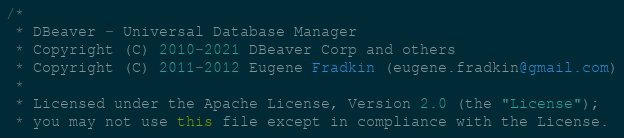<code> <loc_0><loc_0><loc_500><loc_500><_Java_>/*
 * DBeaver - Universal Database Manager
 * Copyright (C) 2010-2021 DBeaver Corp and others
 * Copyright (C) 2011-2012 Eugene Fradkin (eugene.fradkin@gmail.com)
 *
 * Licensed under the Apache License, Version 2.0 (the "License");
 * you may not use this file except in compliance with the License.</code> 